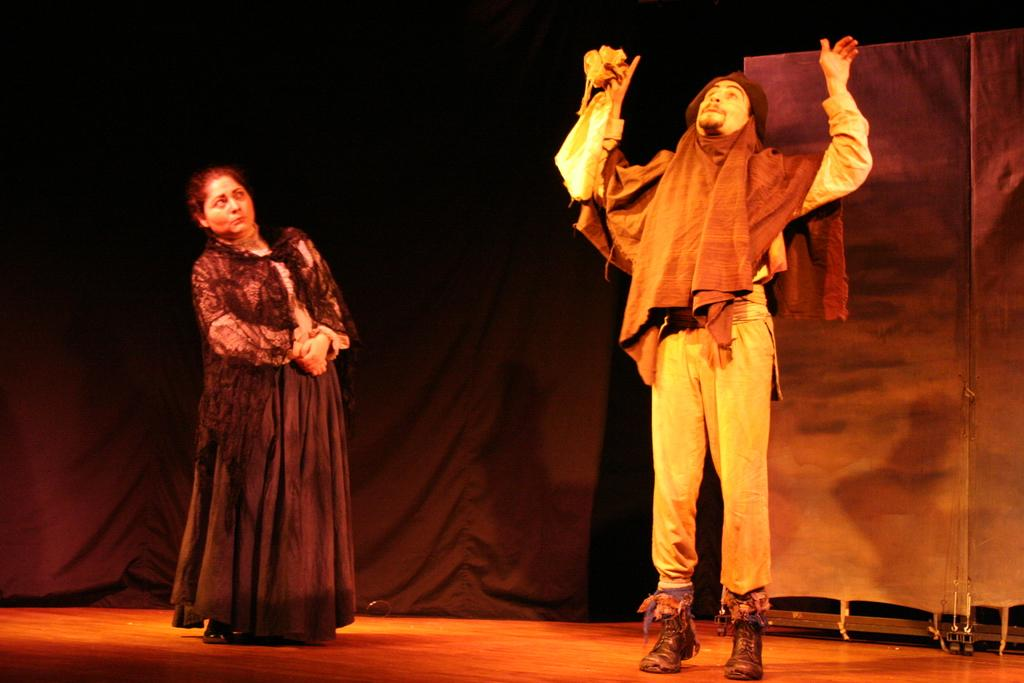How many people are in the image? There are two people in the image. What are the people wearing? The people are wearing dresses. What color is the curtain in the background of the image? The curtain in the background of the image is black. What is the overall color of the background in the image? The background of the image is black. What letters can be seen on the dresses in the image? There is no mention of letters on the dresses in the provided facts, so we cannot determine if any letters are present. 